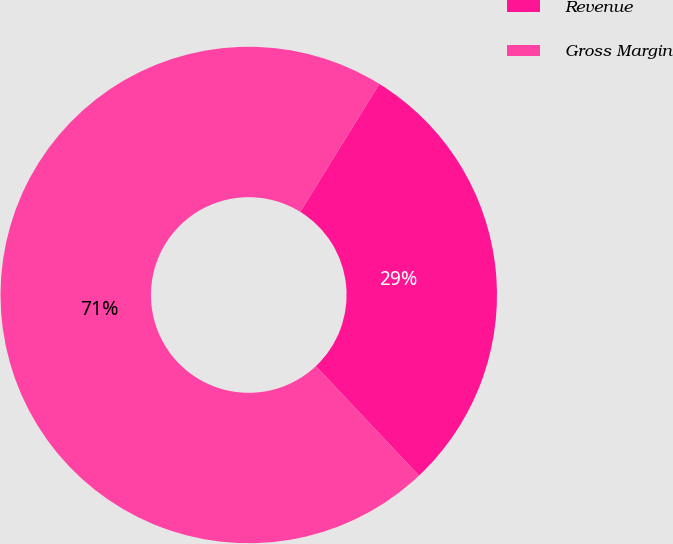<chart> <loc_0><loc_0><loc_500><loc_500><pie_chart><fcel>Revenue<fcel>Gross Margin<nl><fcel>29.15%<fcel>70.85%<nl></chart> 